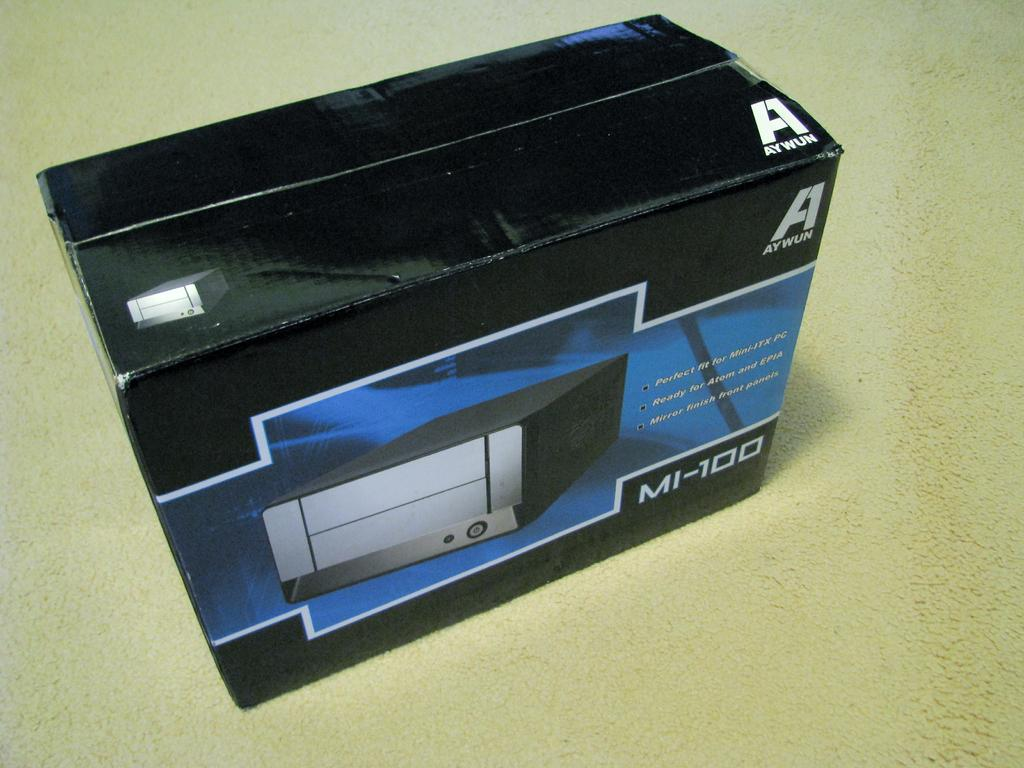Provide a one-sentence caption for the provided image. A box has the brand name Aywun, while this item is the MI-100. 